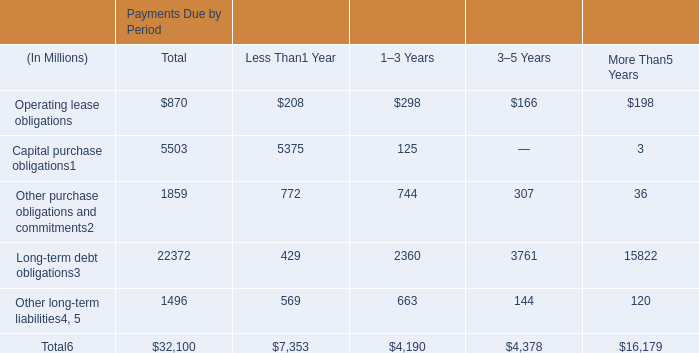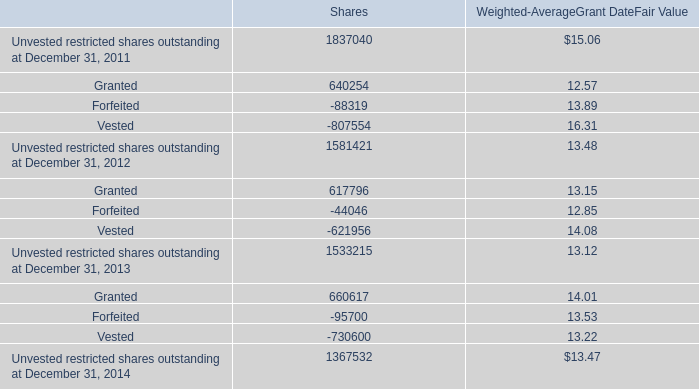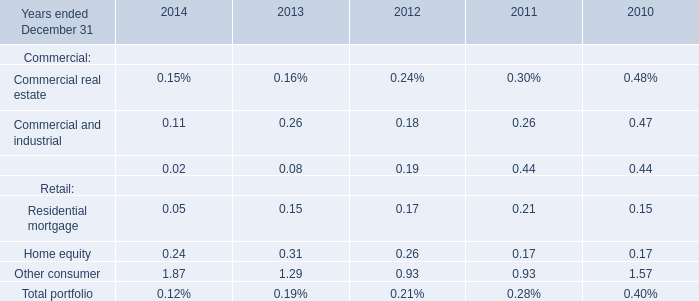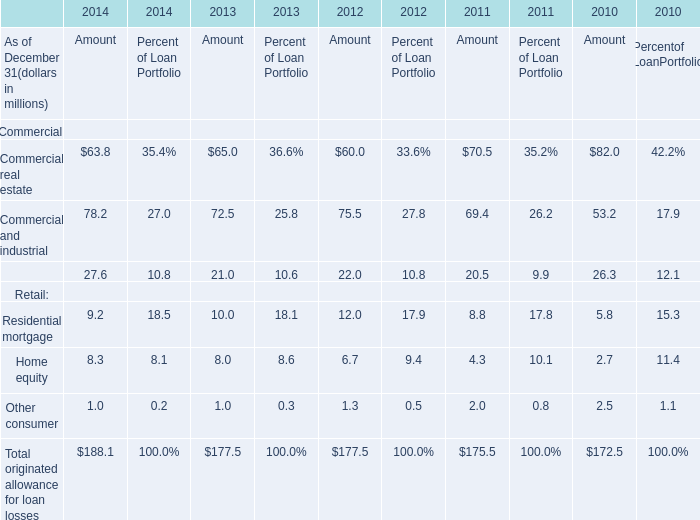Which year is Commercial and industrial greater than 0 ? 
Answer: 2014 2013 2012 2011 2010. 